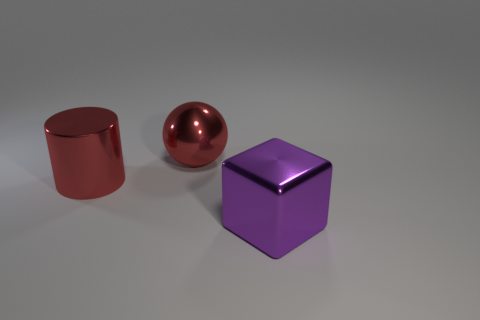Add 1 red cylinders. How many objects exist? 4 Add 2 big metallic cubes. How many big metallic cubes are left? 3 Add 3 purple shiny blocks. How many purple shiny blocks exist? 4 Subtract 0 green cylinders. How many objects are left? 3 Subtract all red objects. Subtract all small metal cylinders. How many objects are left? 1 